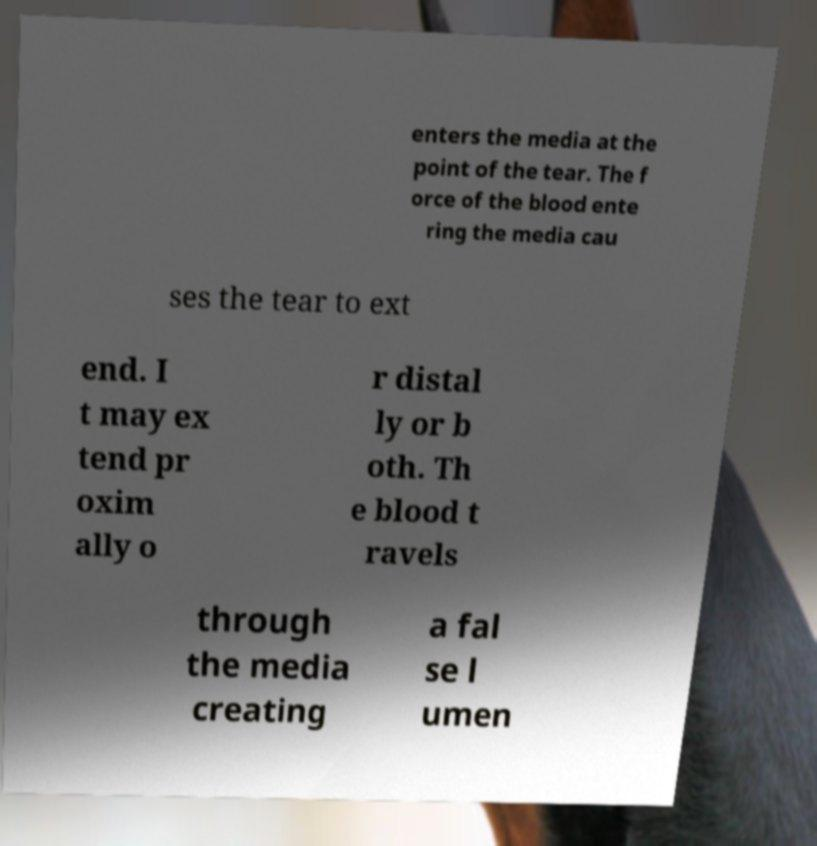What messages or text are displayed in this image? I need them in a readable, typed format. enters the media at the point of the tear. The f orce of the blood ente ring the media cau ses the tear to ext end. I t may ex tend pr oxim ally o r distal ly or b oth. Th e blood t ravels through the media creating a fal se l umen 